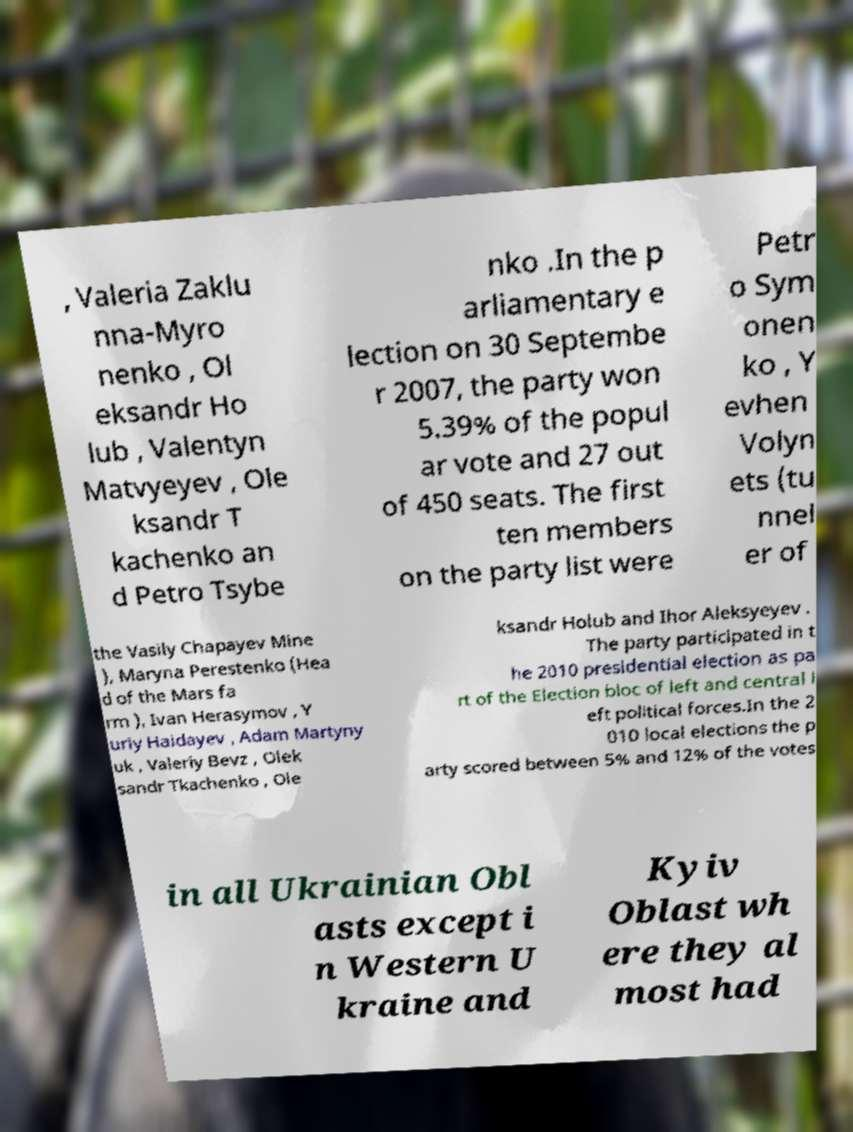Can you accurately transcribe the text from the provided image for me? , Valeria Zaklu nna-Myro nenko , Ol eksandr Ho lub , Valentyn Matvyeyev , Ole ksandr T kachenko an d Petro Tsybe nko .In the p arliamentary e lection on 30 Septembe r 2007, the party won 5.39% of the popul ar vote and 27 out of 450 seats. The first ten members on the party list were Petr o Sym onen ko , Y evhen Volyn ets (tu nnel er of the Vasily Chapayev Mine ), Maryna Perestenko (Hea d of the Mars fa rm ), Ivan Herasymov , Y uriy Haidayev , Adam Martyny uk , Valeriy Bevz , Olek sandr Tkachenko , Ole ksandr Holub and Ihor Aleksyeyev . The party participated in t he 2010 presidential election as pa rt of the Election bloc of left and central l eft political forces.In the 2 010 local elections the p arty scored between 5% and 12% of the votes in all Ukrainian Obl asts except i n Western U kraine and Kyiv Oblast wh ere they al most had 